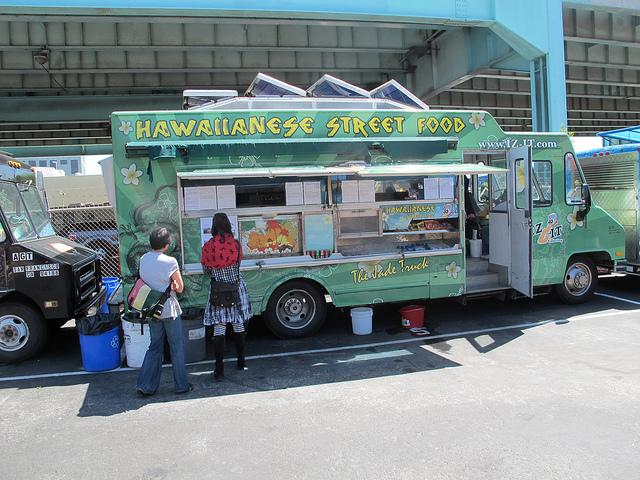How many people are waiting?
Short answer required. 2. Is this a food truck?
Keep it brief. Yes. Is someone handing out food?
Answer briefly. Yes. 